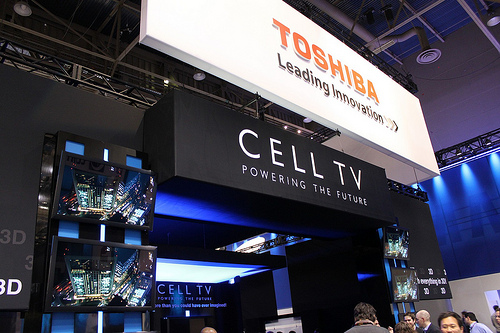<image>
Is the poster under the wall? Yes. The poster is positioned underneath the wall, with the wall above it in the vertical space. 